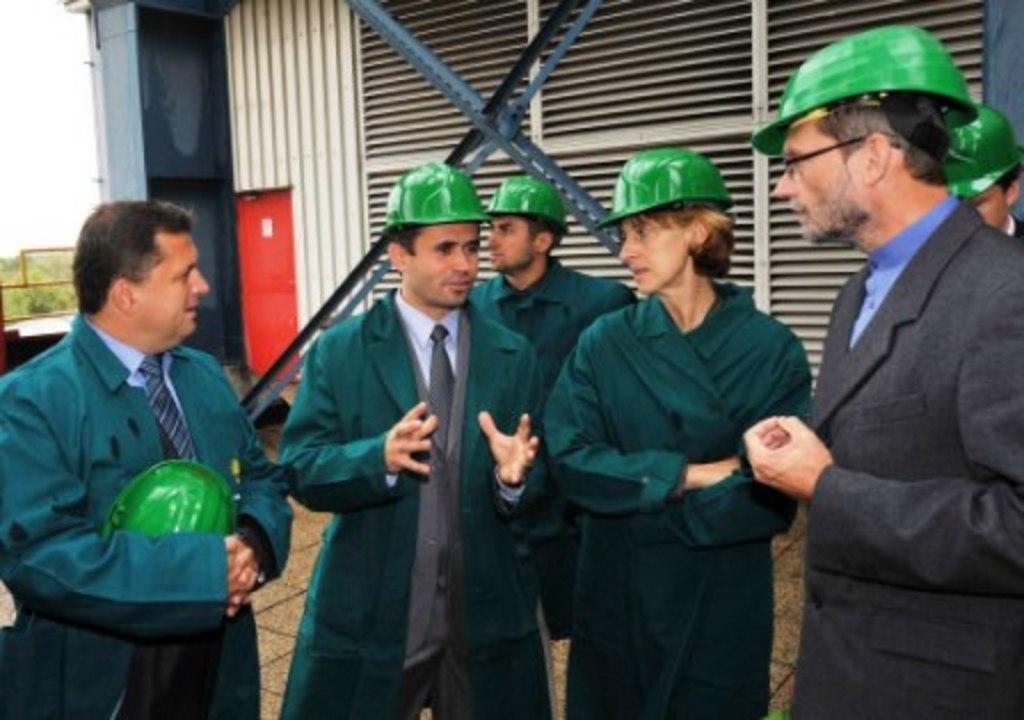Please provide a concise description of this image. In this image six people were standing by wearing green helmets. At the back side there is a building and trees. 